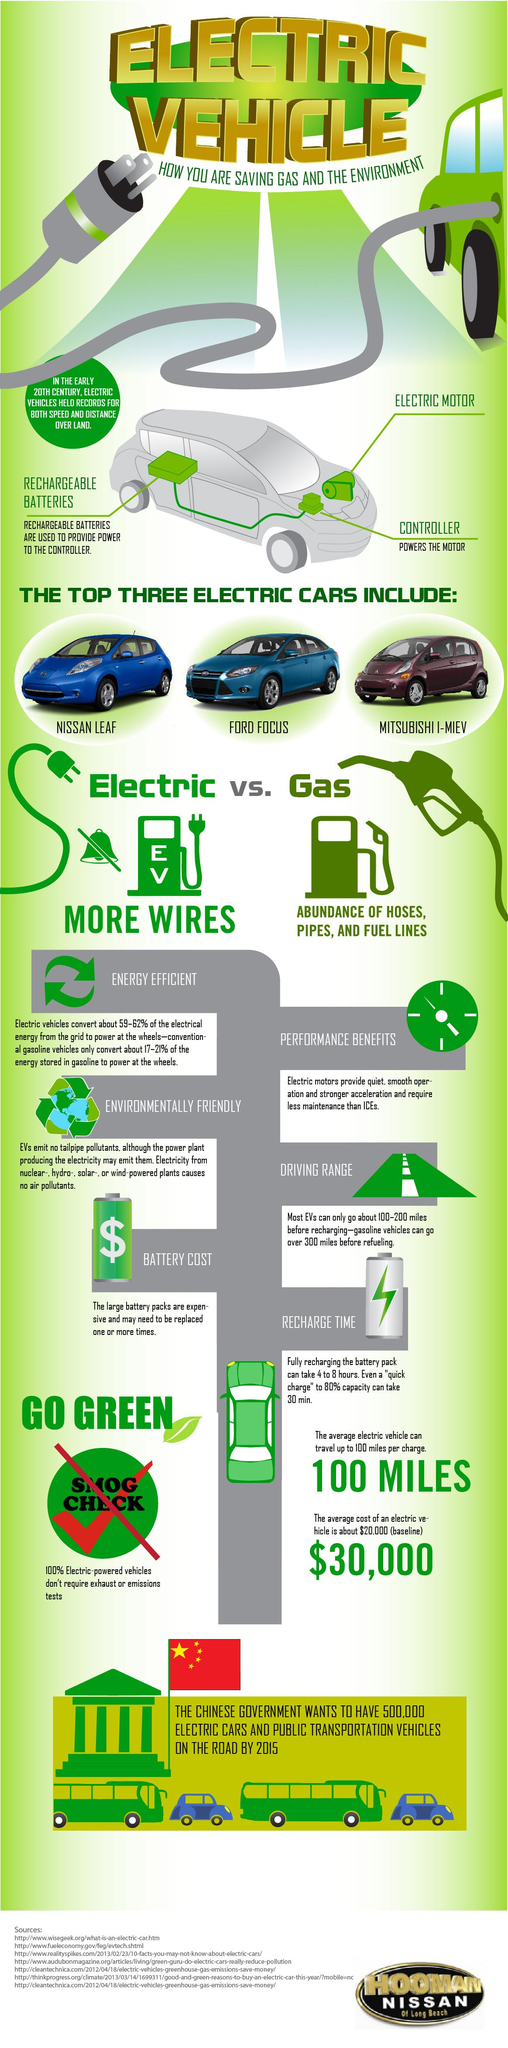List a handful of essential elements in this visual. Seven sources are listed at the bottom. The main components of an electric vehicle are the rechargeable batteries, electric motor, and controller, which are crucial for the vehicle's operation and efficiency. 